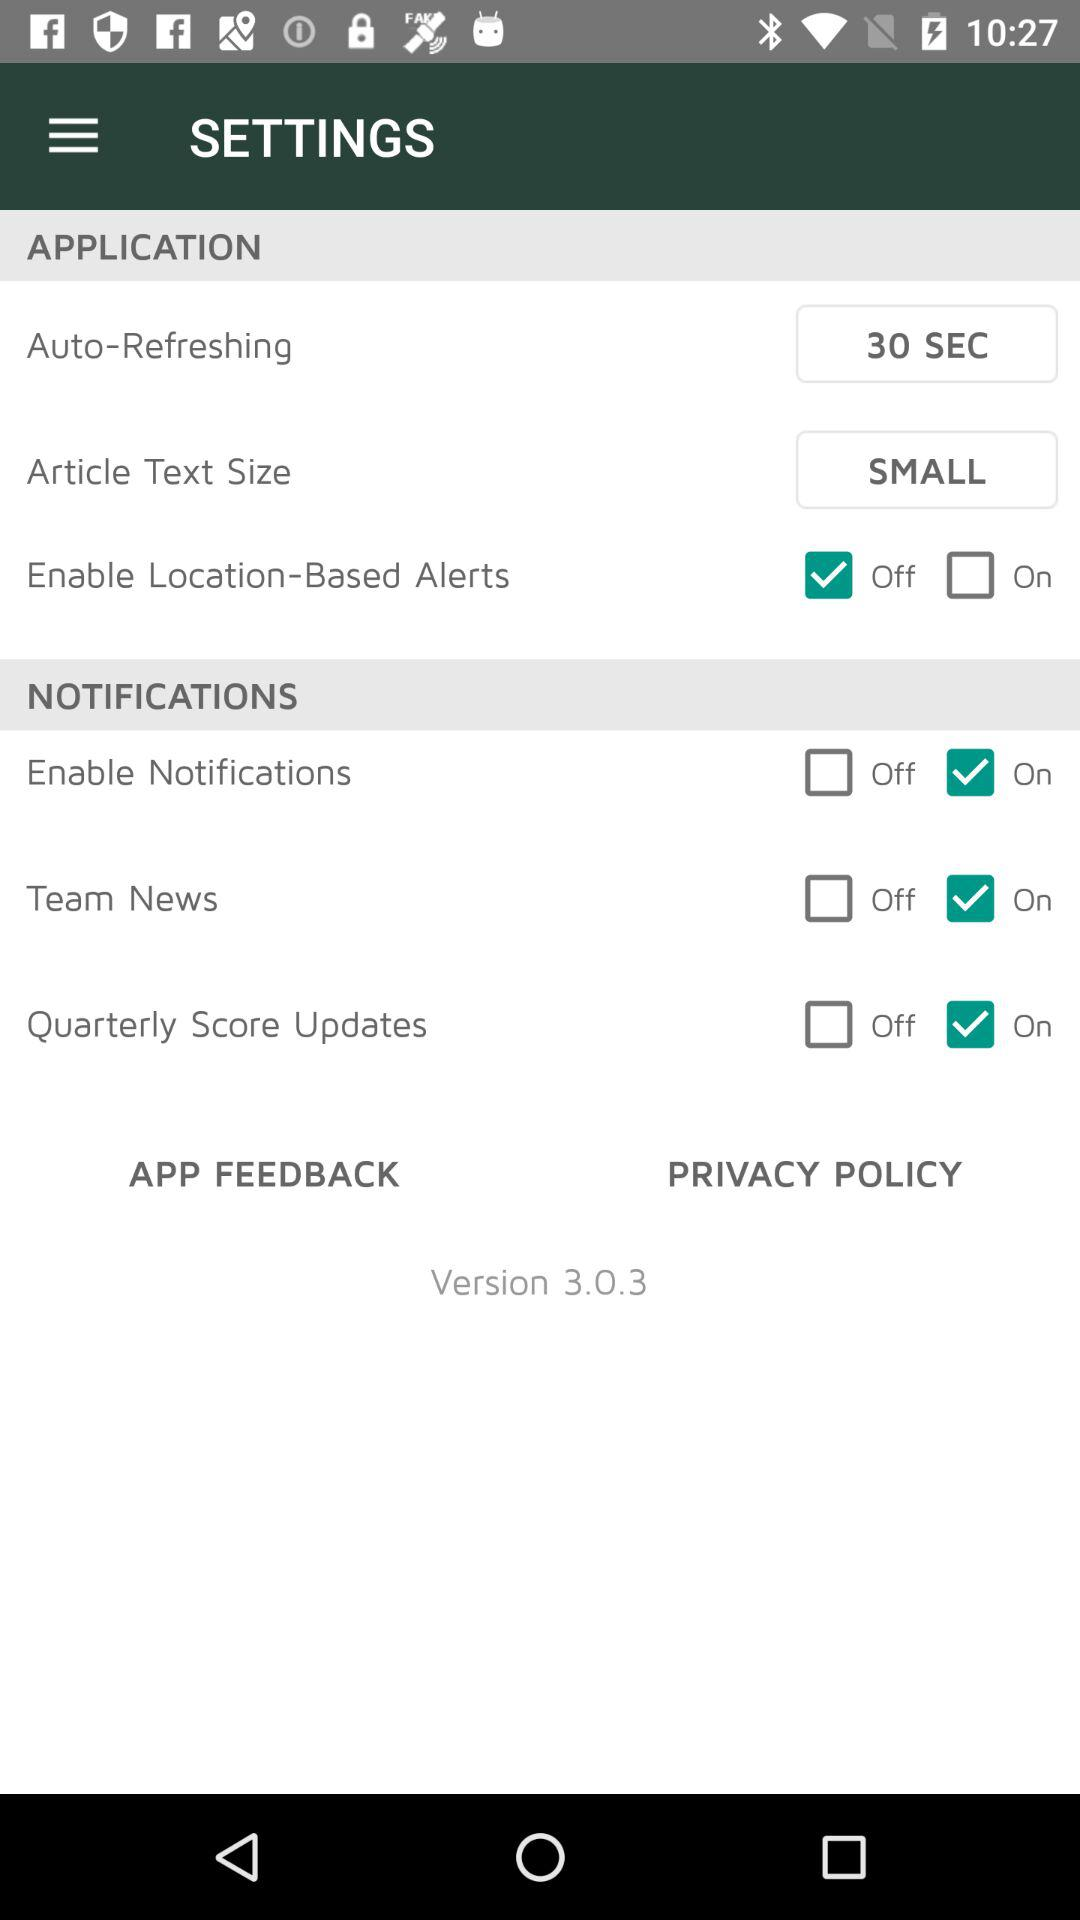What is the status of "Enable Location-Based Alerts"? The status of "Enable Location-Based Alerts" is "off". 